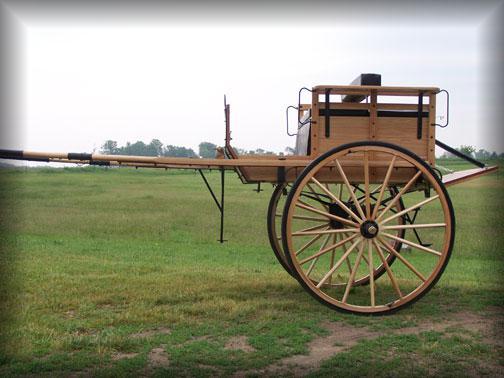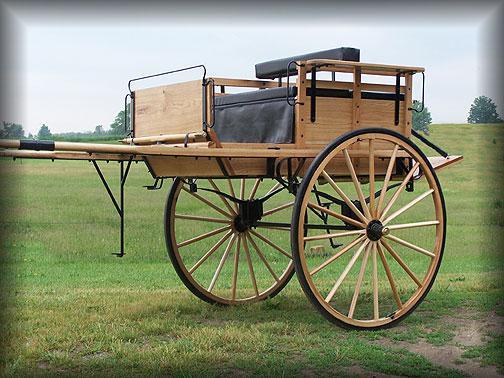The first image is the image on the left, the second image is the image on the right. Evaluate the accuracy of this statement regarding the images: "Both carts are pulled by brown horses.". Is it true? Answer yes or no. No. 